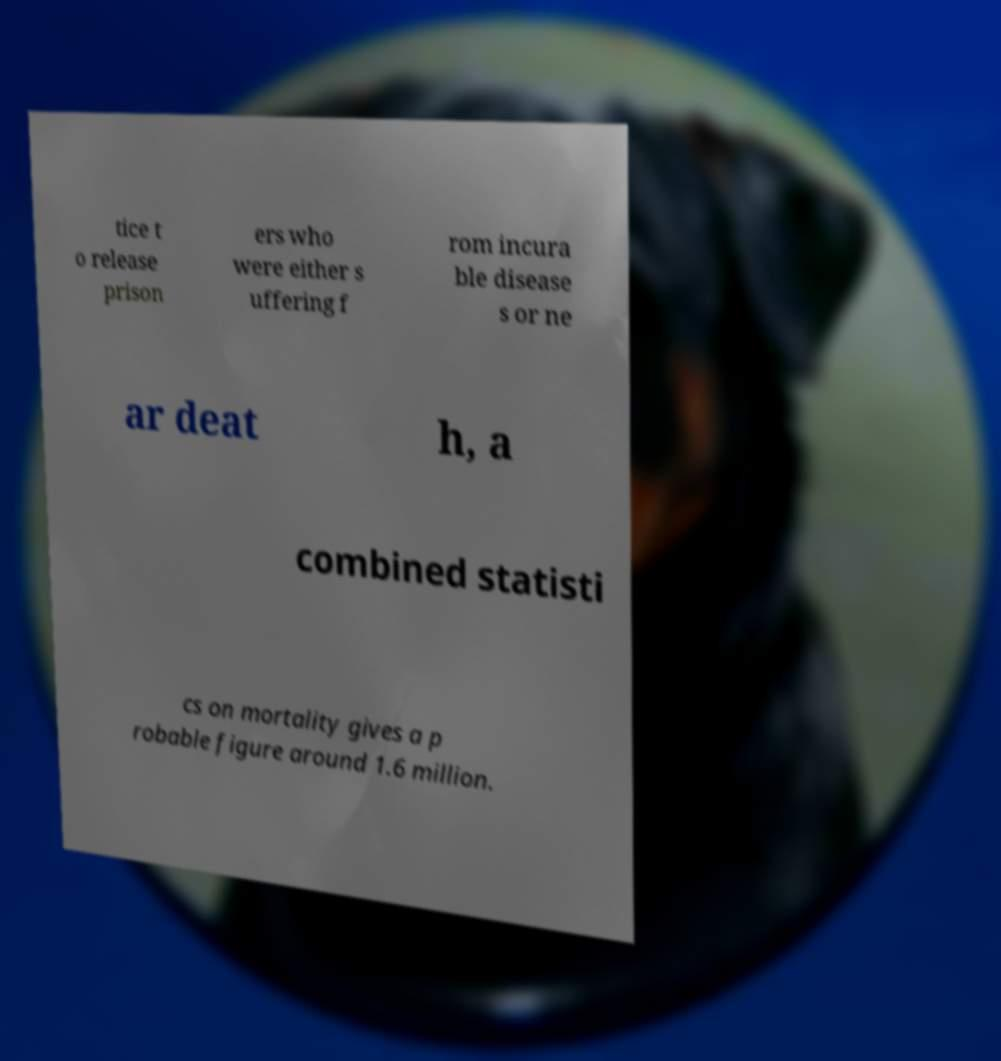Please identify and transcribe the text found in this image. tice t o release prison ers who were either s uffering f rom incura ble disease s or ne ar deat h, a combined statisti cs on mortality gives a p robable figure around 1.6 million. 